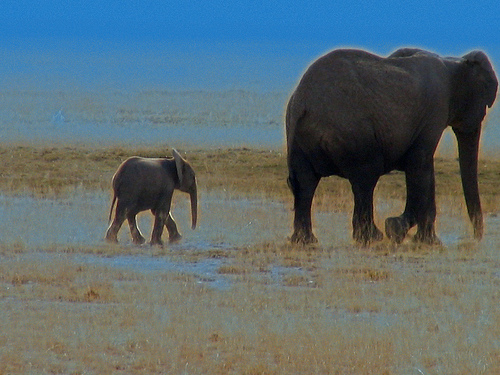<image>
Is there a elephant on the water? Yes. Looking at the image, I can see the elephant is positioned on top of the water, with the water providing support. 